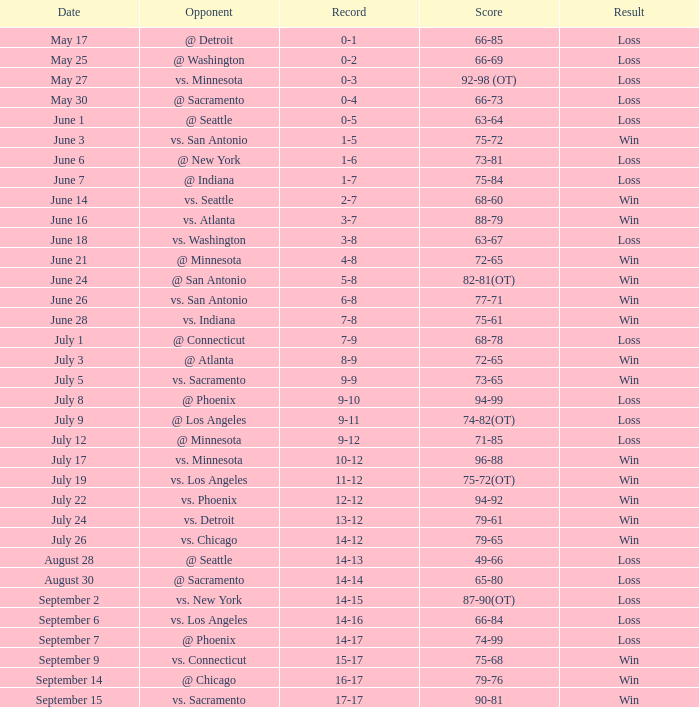What is the Record of the game on June 24? 5-8. 